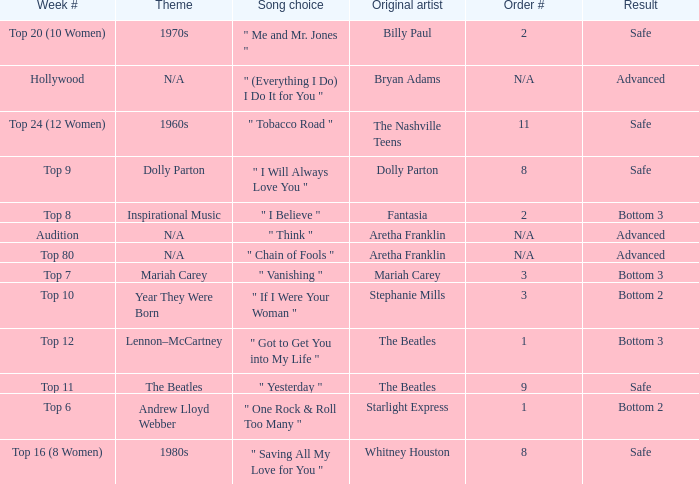Name the order number for the beatles and result is safe 9.0. 